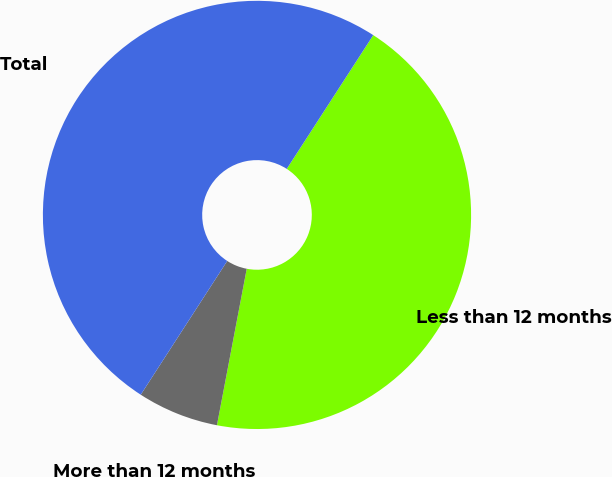<chart> <loc_0><loc_0><loc_500><loc_500><pie_chart><fcel>Less than 12 months<fcel>More than 12 months<fcel>Total<nl><fcel>43.86%<fcel>6.14%<fcel>50.0%<nl></chart> 